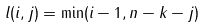Convert formula to latex. <formula><loc_0><loc_0><loc_500><loc_500>l ( i , j ) = \min ( i - 1 , n - k - j )</formula> 